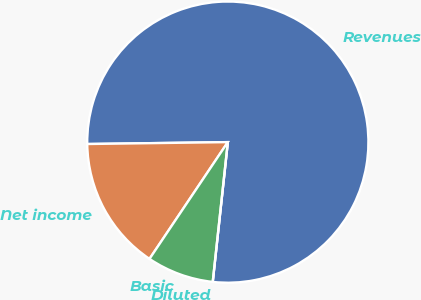Convert chart to OTSL. <chart><loc_0><loc_0><loc_500><loc_500><pie_chart><fcel>Revenues<fcel>Net income<fcel>Basic<fcel>Diluted<nl><fcel>76.92%<fcel>15.38%<fcel>7.69%<fcel>0.0%<nl></chart> 